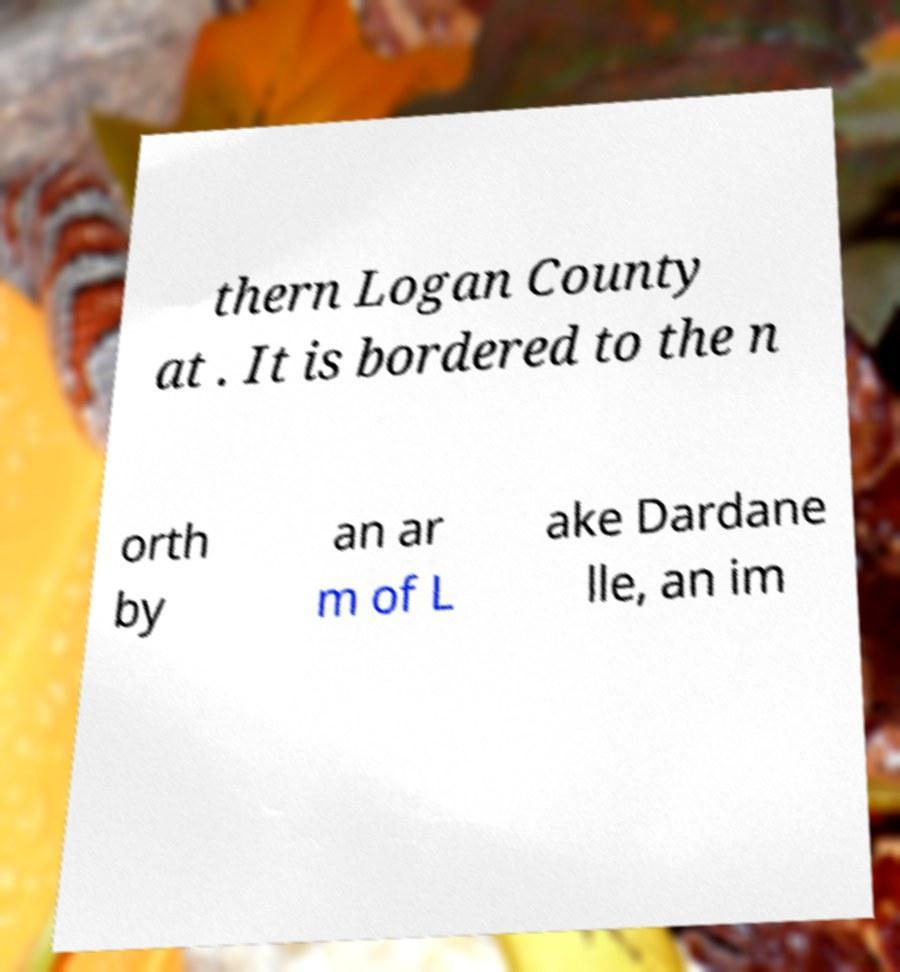Can you accurately transcribe the text from the provided image for me? thern Logan County at . It is bordered to the n orth by an ar m of L ake Dardane lle, an im 